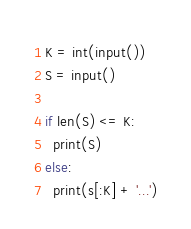Convert code to text. <code><loc_0><loc_0><loc_500><loc_500><_Python_>K = int(input())
S = input()

if len(S) <= K:
  print(S)
else:
  print(s[:K] + '...')</code> 